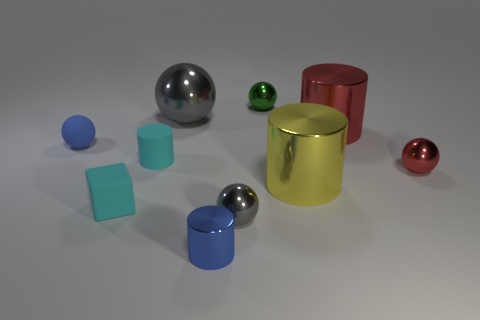What materials do these objects appear to be made of? The objects in the image appear to be made of various materials. The ones with a reflective sheen, like the gray and green spheres, look metallic. The red and yellow cylinders might be made of a matte painted metal or plastic due to their less reflective quality, and the blue cubes appear plastic given their opaque and slightly matte finish.  Are the sizes of the objects consistent with one another? The sizes of the objects vary relative to each other. There are small spheres and larger ones, and the cylinders and cubes also differ in size. This assortment of sizes helps to create a visually interesting composition and could be representative of diversity in forms found in real-world objects. 